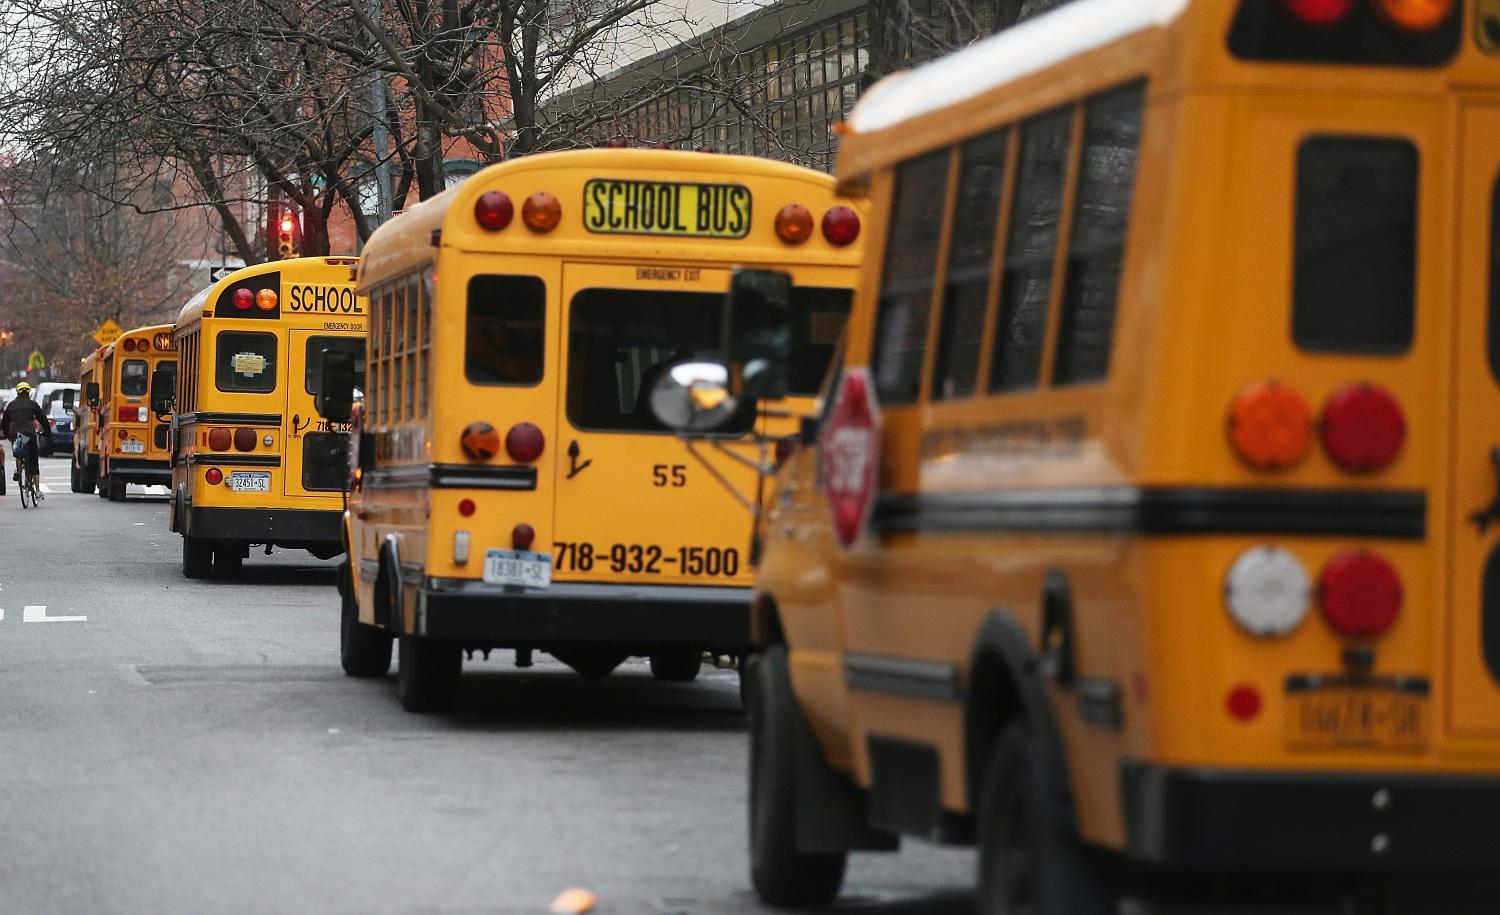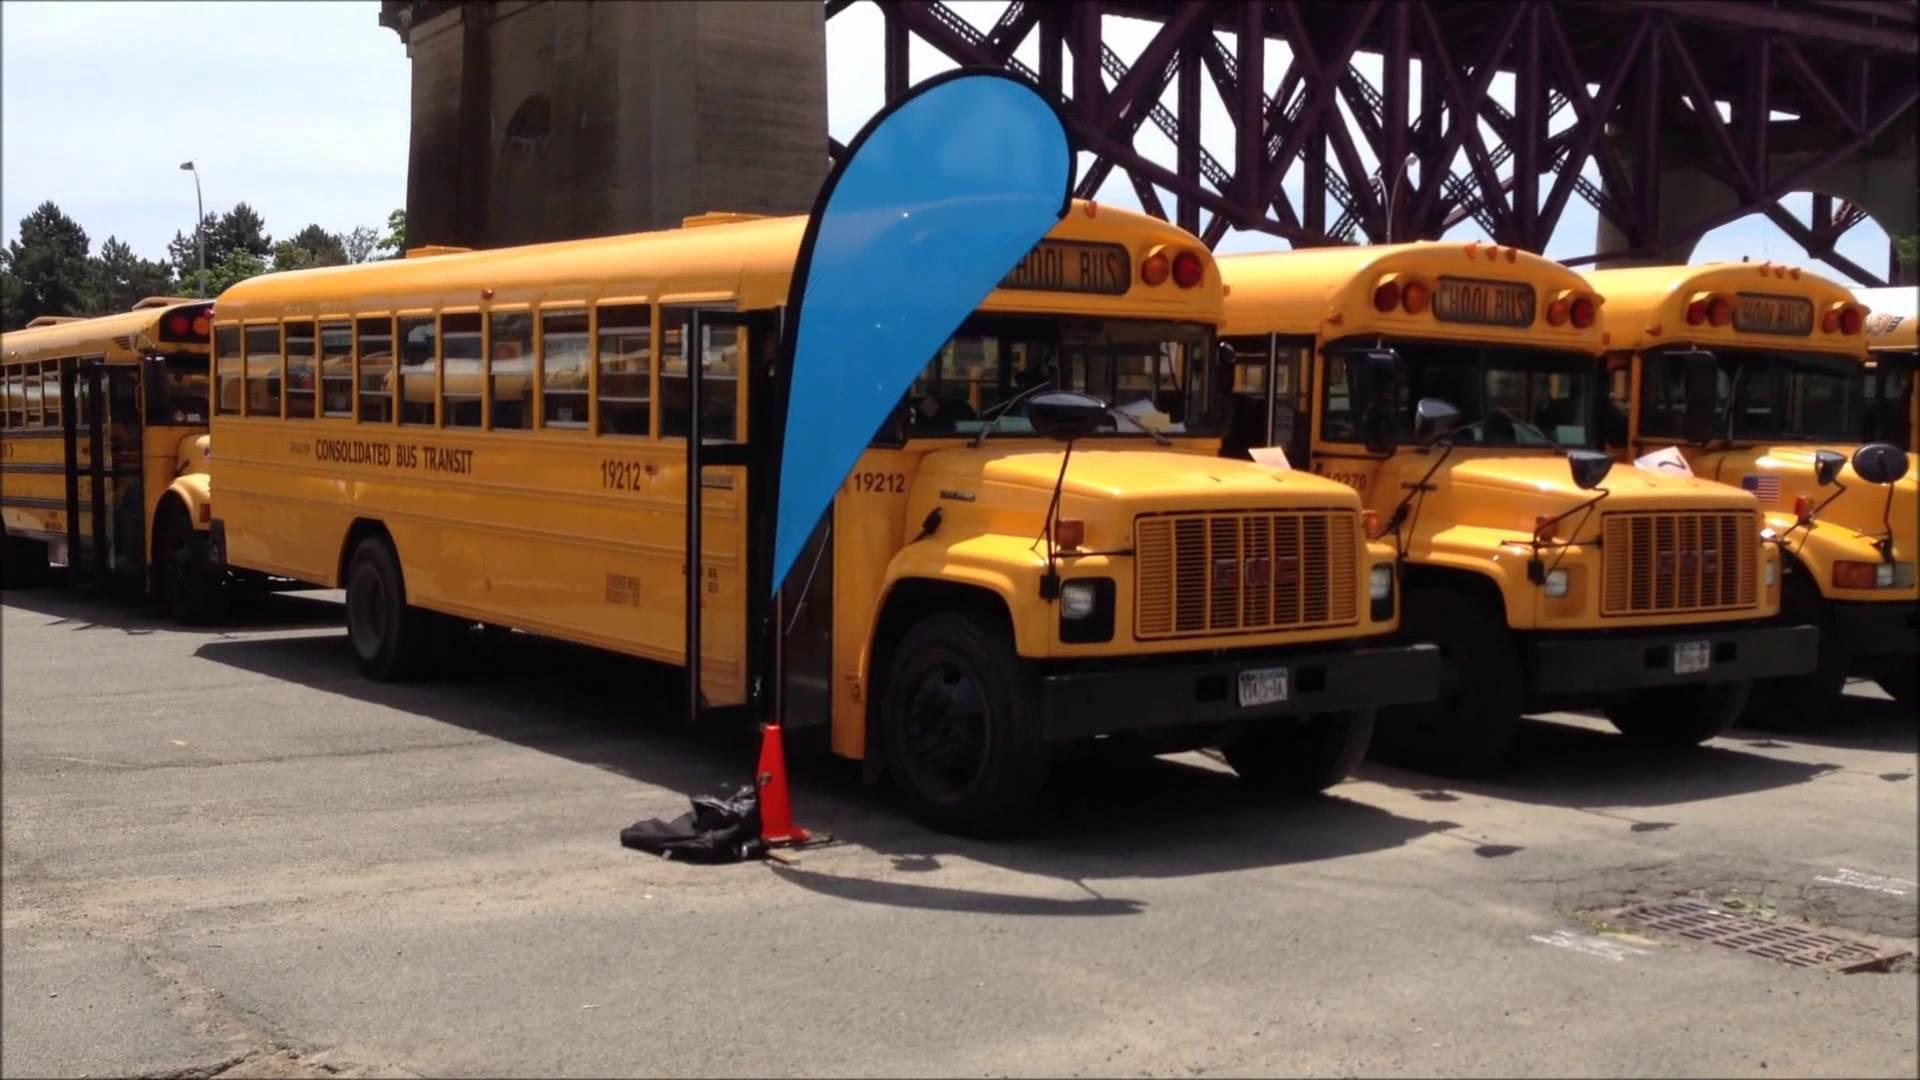The first image is the image on the left, the second image is the image on the right. Evaluate the accuracy of this statement regarding the images: "The left image shows at least one bus heading away from the camera, and the right image shows at least one forward-angled bus.". Is it true? Answer yes or no. Yes. The first image is the image on the left, the second image is the image on the right. Considering the images on both sides, is "In one of the images you can see the tail lights of a school bus." valid? Answer yes or no. Yes. 